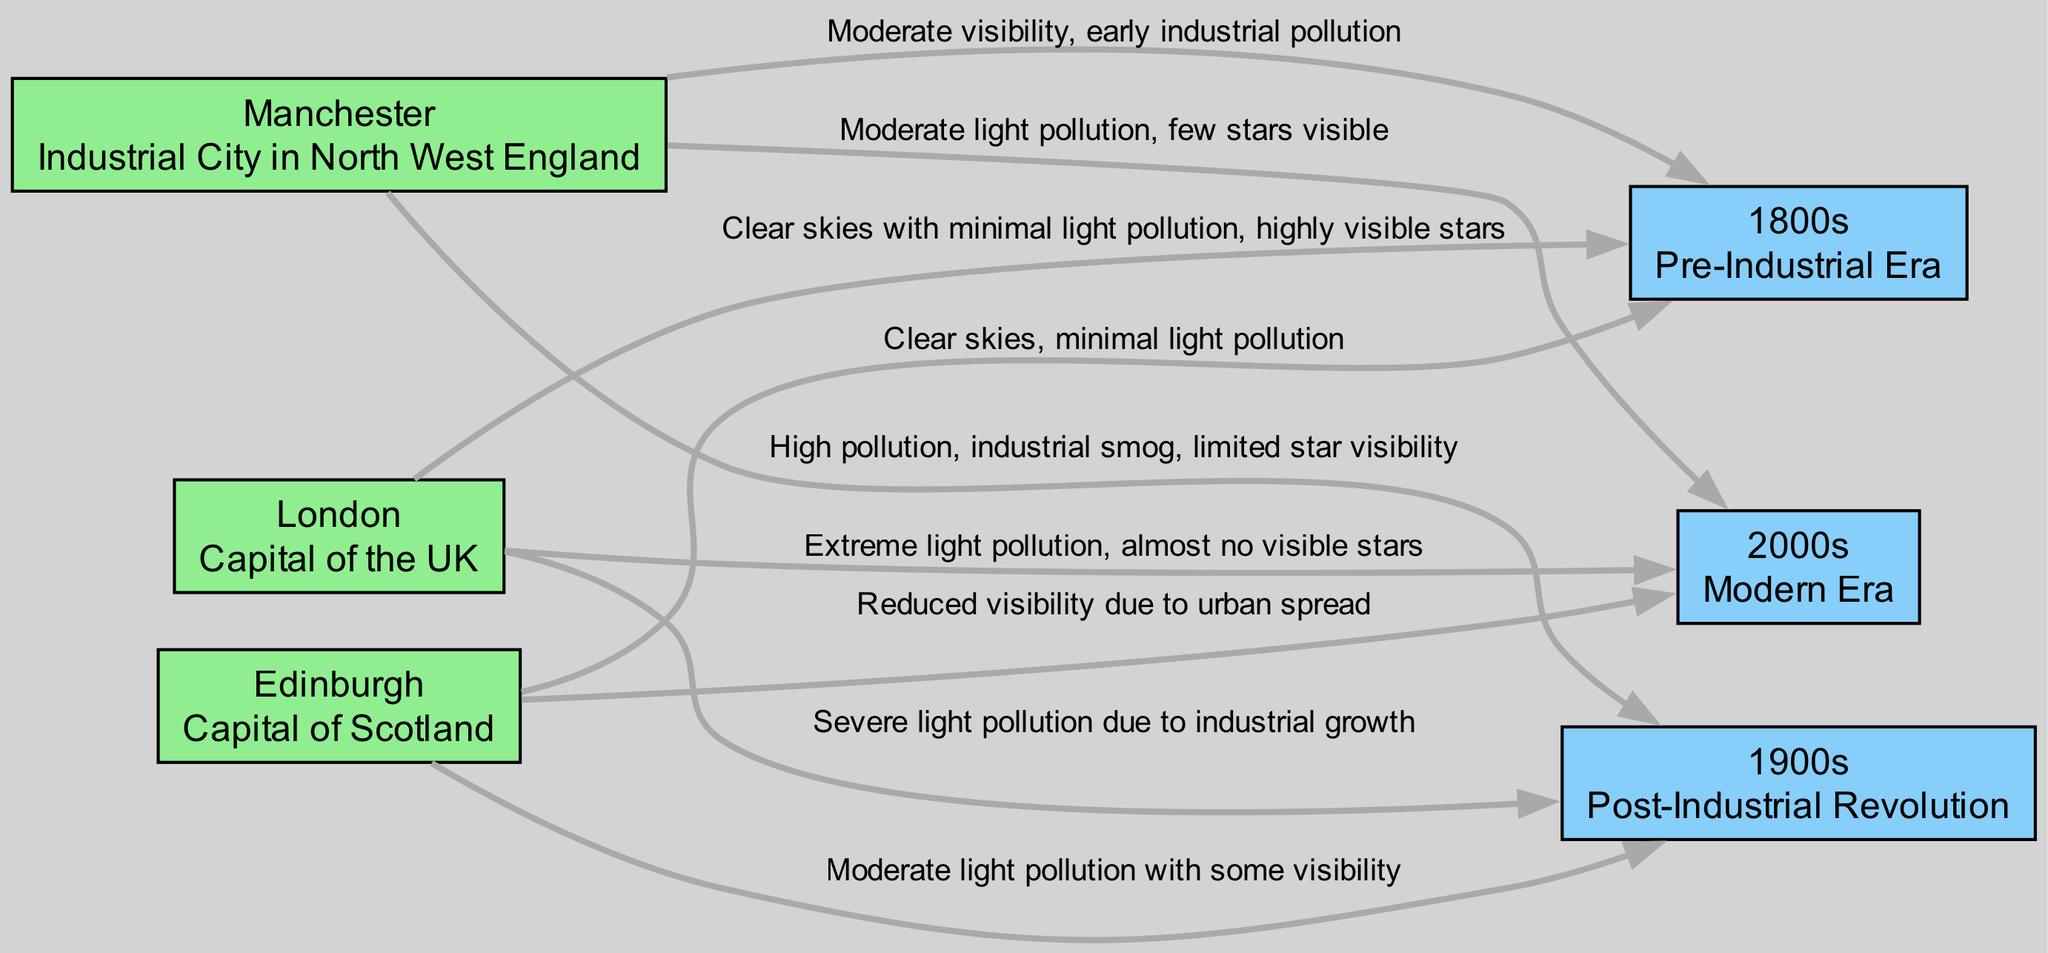What star visibility condition describes London in the 1800s? The diagram shows that London had "Clear skies with minimal light pollution, highly visible stars" during the 1800s, as indicated by the edge connecting the city node to the period node.
Answer: Clear skies with minimal light pollution, highly visible stars Which city had the worst star visibility in the 2000s? The diagram indicates that London had "Extreme light pollution, almost no visible stars" in the 2000s, making it the city with the worst visibility.
Answer: London How many cities are represented in the diagram? There are three city nodes: London, Manchester, and Edinburgh, which can be counted directly from the city labels.
Answer: 3 What is the visibility of Manchester in the 1900s? Manchester's visibility in the 1900s is described as "High pollution, industrial smog, limited star visibility" which is stated in the diagram's edge information.
Answer: High pollution, industrial smog, limited star visibility How did Edinburgh's star visibility change from the 1900s to the 2000s? The visibility went from "Moderate light pollution with some visibility" in the 1900s to "Reduced visibility due to urban spread" in the 2000s, showing a decline in clarity.
Answer: Decline in clarity Which period had the best star visibility overall across the cities? The diagram shows that the 1800s had the best visibility across all cities, as the descriptions for each city indicate minimal light pollution.
Answer: 1800s What is the relationship between Manchester and the 2000s based on the diagram? The edge from Manchester to the 2000s indicates that it has "Moderate light pollution, few stars visible," which shows a deterioration in visibility compared to earlier periods.
Answer: Moderate light pollution, few stars visible What indicates extreme light pollution in London during the 2000s? The description in the edge from London to the 2000s states "Extreme light pollution, almost no visible stars," which directly indicates the level of pollution.
Answer: Extreme light pollution, almost no visible stars How many edges connect the cities to the periods in the diagram? There are a total of nine edges as each city is connected to each period in the diagram, illustrating visibility changes over time.
Answer: 9 